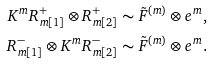<formula> <loc_0><loc_0><loc_500><loc_500>K ^ { m } R ^ { + } _ { m [ 1 ] } \otimes R ^ { + } _ { m [ 2 ] } & \sim \tilde { F } ^ { ( m ) } \otimes e ^ { m } , \\ R ^ { - } _ { m [ 1 ] } \otimes K ^ { m } R ^ { - } _ { m [ 2 ] } & \sim \tilde { F } ^ { ( m ) } \otimes e ^ { m } .</formula> 